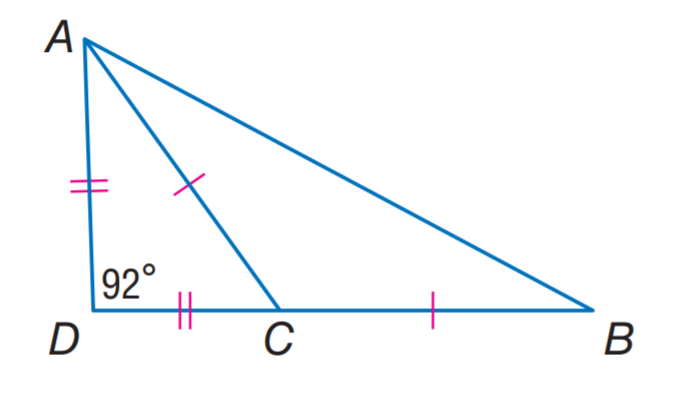Answer the mathemtical geometry problem and directly provide the correct option letter.
Question: Find m \angle A C B.
Choices: A: 92 B: 102 C: 136 D: 144 C 